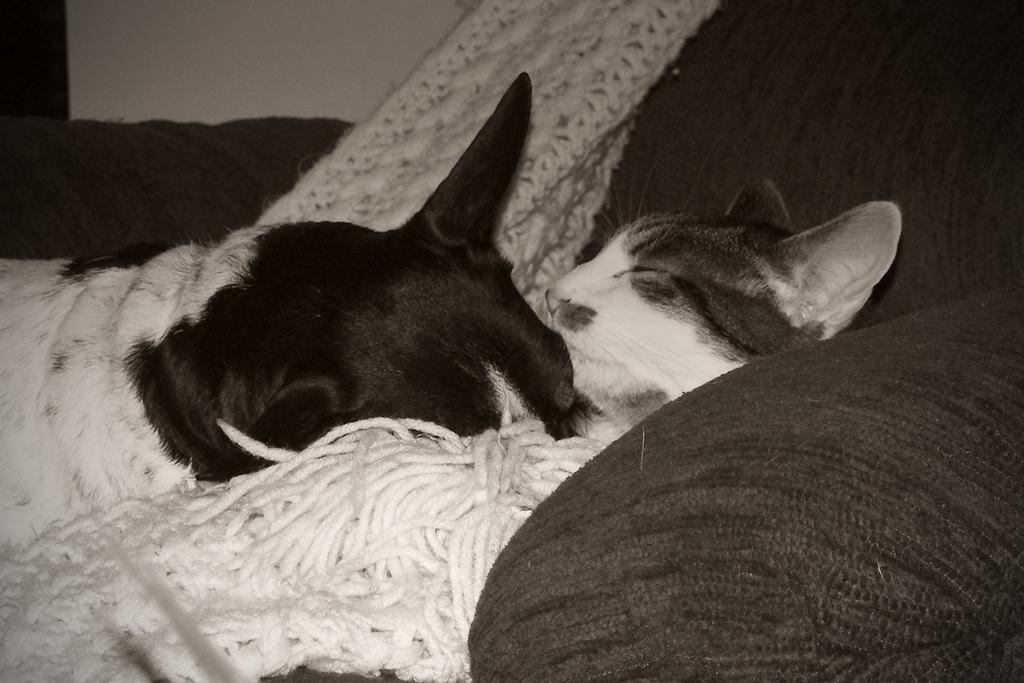What type of animals can be seen in the picture? There is a dog and a cat in the picture. Where are the dog and cat located in the image? Both the dog and cat are on a couch. What is the most efficient route for the dog to take to reach the cat in the image? There is no need for the dog to reach the cat in the image, as they are both already on the couch together. 